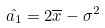<formula> <loc_0><loc_0><loc_500><loc_500>\hat { a _ { 1 } } = 2 \overline { x } - \sigma ^ { 2 }</formula> 